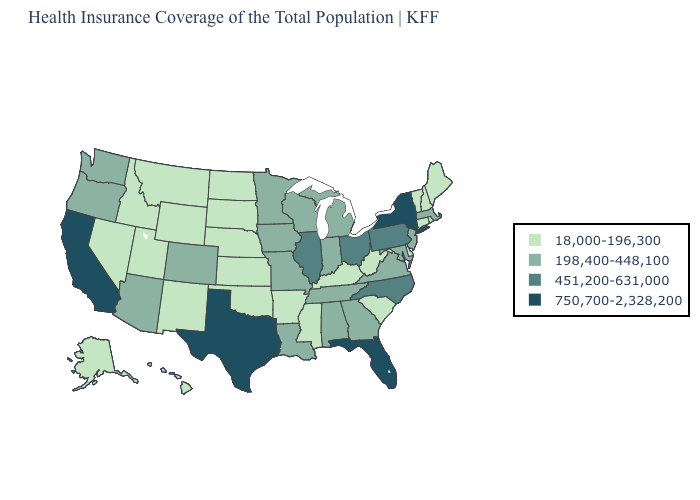Name the states that have a value in the range 750,700-2,328,200?
Write a very short answer. California, Florida, New York, Texas. What is the value of New York?
Write a very short answer. 750,700-2,328,200. How many symbols are there in the legend?
Answer briefly. 4. Does Vermont have the highest value in the Northeast?
Short answer required. No. What is the lowest value in states that border Nevada?
Answer briefly. 18,000-196,300. Is the legend a continuous bar?
Answer briefly. No. Which states hav the highest value in the MidWest?
Keep it brief. Illinois, Ohio. Does the map have missing data?
Be succinct. No. Is the legend a continuous bar?
Keep it brief. No. Among the states that border Washington , does Idaho have the highest value?
Write a very short answer. No. Which states have the highest value in the USA?
Give a very brief answer. California, Florida, New York, Texas. What is the value of Missouri?
Short answer required. 198,400-448,100. How many symbols are there in the legend?
Quick response, please. 4. Does Idaho have a lower value than Washington?
Give a very brief answer. Yes. Name the states that have a value in the range 18,000-196,300?
Short answer required. Alaska, Arkansas, Connecticut, Delaware, Hawaii, Idaho, Kansas, Kentucky, Maine, Mississippi, Montana, Nebraska, Nevada, New Hampshire, New Mexico, North Dakota, Oklahoma, Rhode Island, South Carolina, South Dakota, Utah, Vermont, West Virginia, Wyoming. 